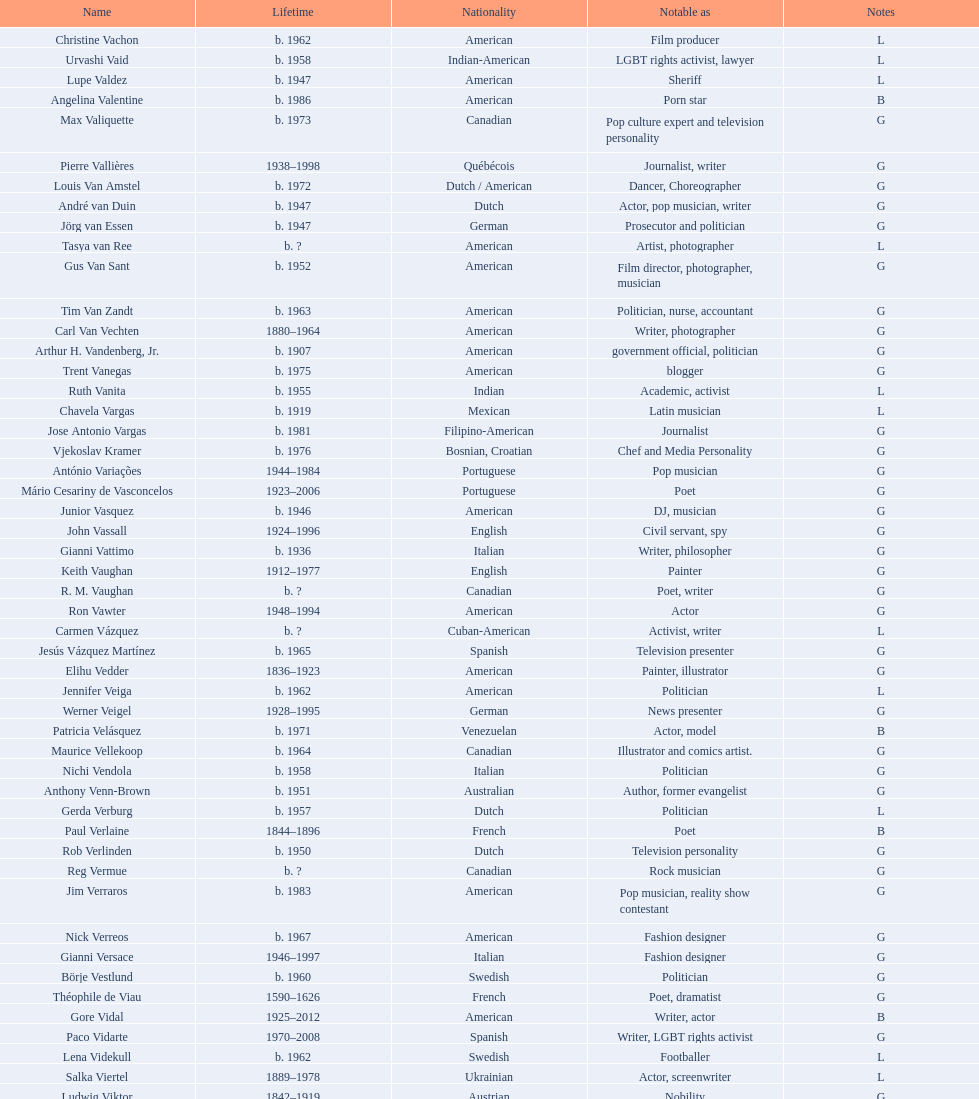Which nationality has the most people associated with it? American. 